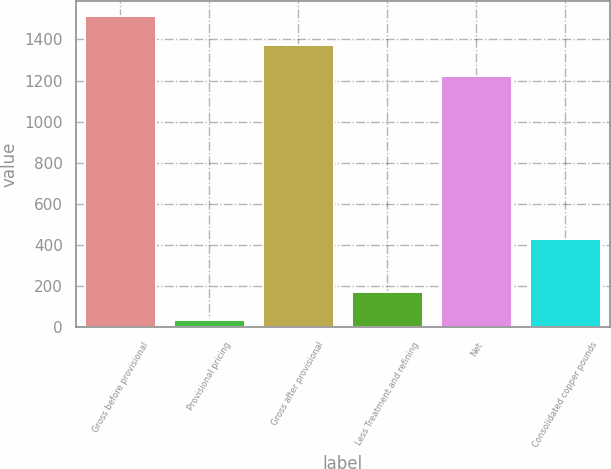<chart> <loc_0><loc_0><loc_500><loc_500><bar_chart><fcel>Gross before provisional<fcel>Provisional pricing<fcel>Gross after provisional<fcel>Less Treatment and refining<fcel>Net<fcel>Consolidated copper pounds<nl><fcel>1511.5<fcel>34<fcel>1374<fcel>171.5<fcel>1221<fcel>428<nl></chart> 